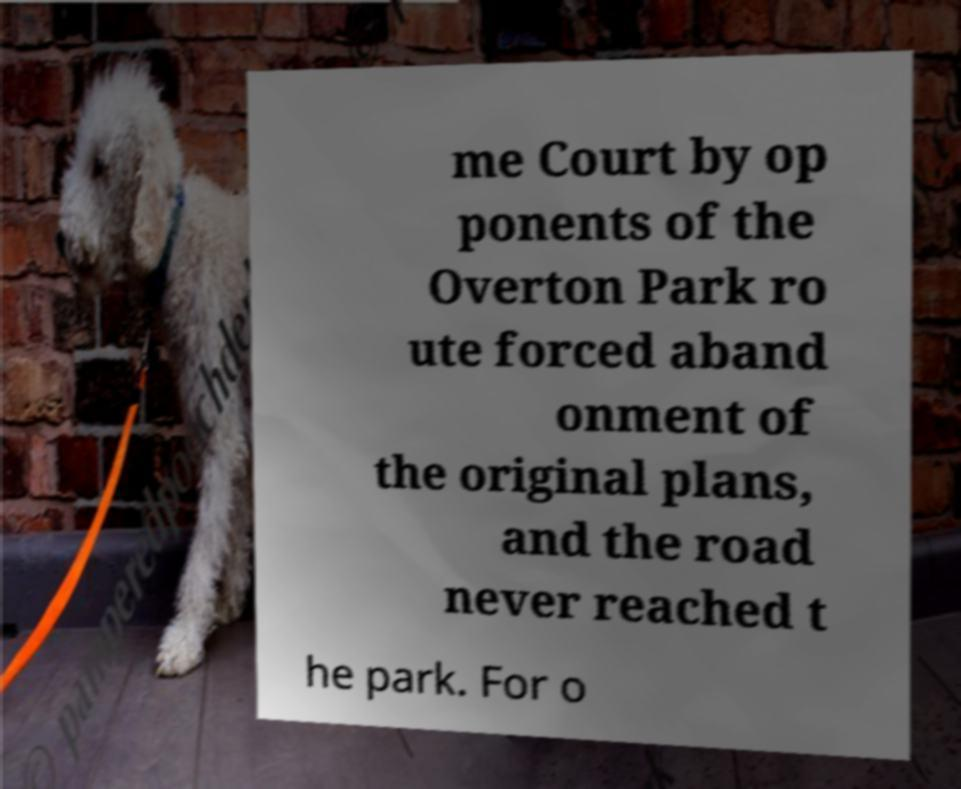Can you read and provide the text displayed in the image?This photo seems to have some interesting text. Can you extract and type it out for me? me Court by op ponents of the Overton Park ro ute forced aband onment of the original plans, and the road never reached t he park. For o 